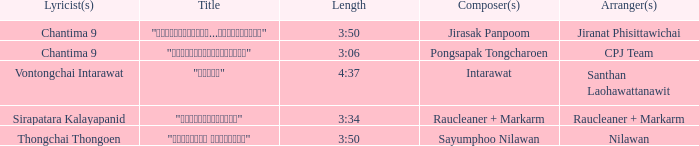Who was the composer of "ขอโทษ"? Intarawat. 